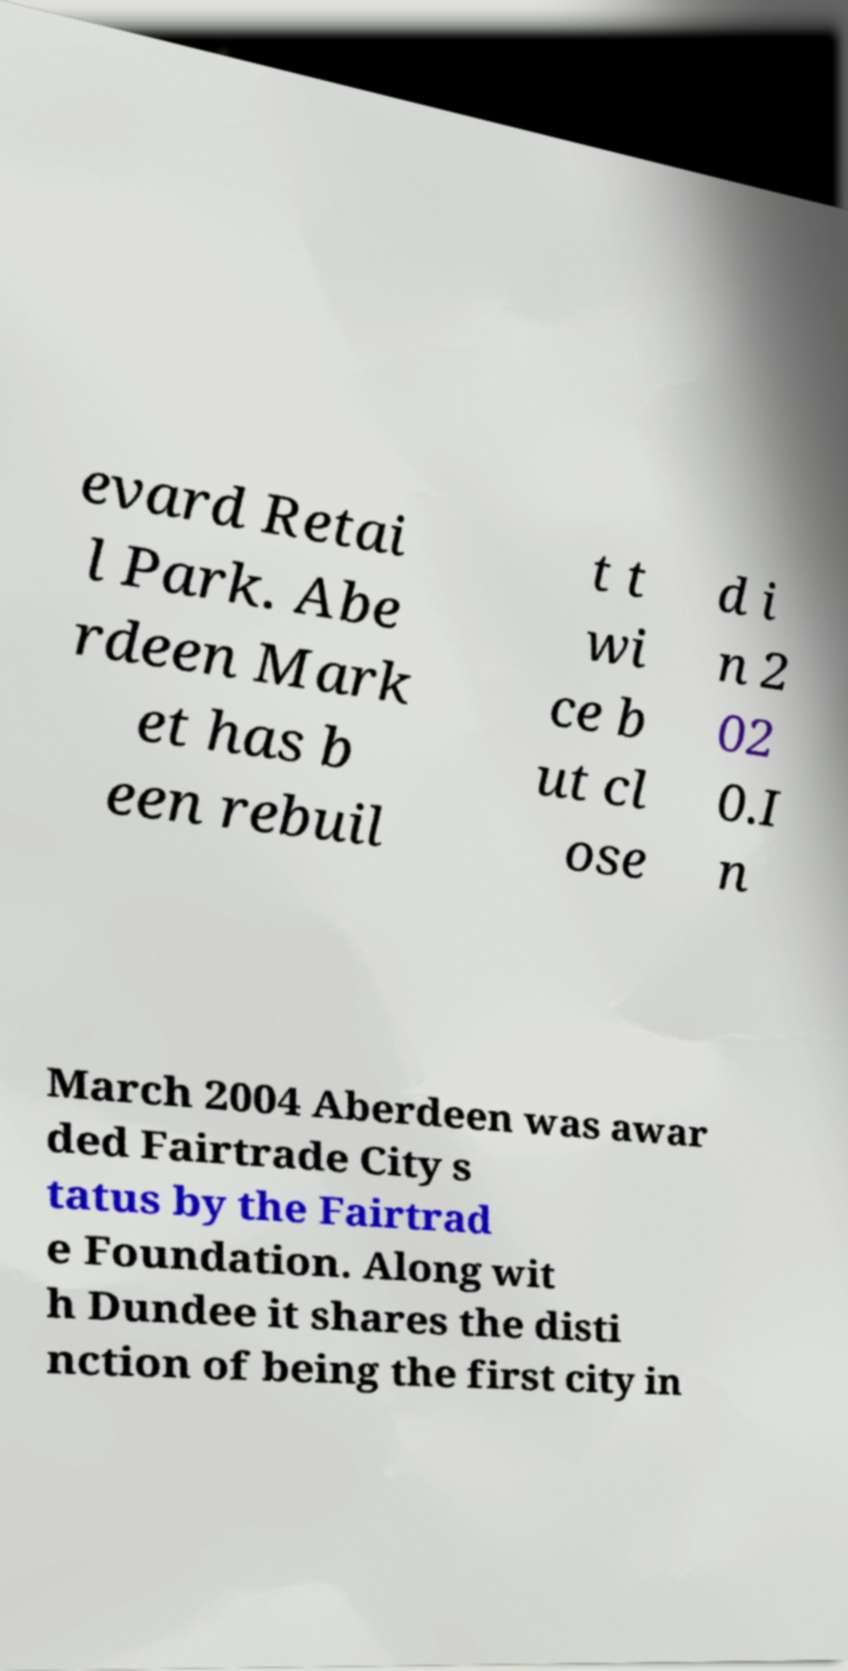Please read and relay the text visible in this image. What does it say? evard Retai l Park. Abe rdeen Mark et has b een rebuil t t wi ce b ut cl ose d i n 2 02 0.I n March 2004 Aberdeen was awar ded Fairtrade City s tatus by the Fairtrad e Foundation. Along wit h Dundee it shares the disti nction of being the first city in 